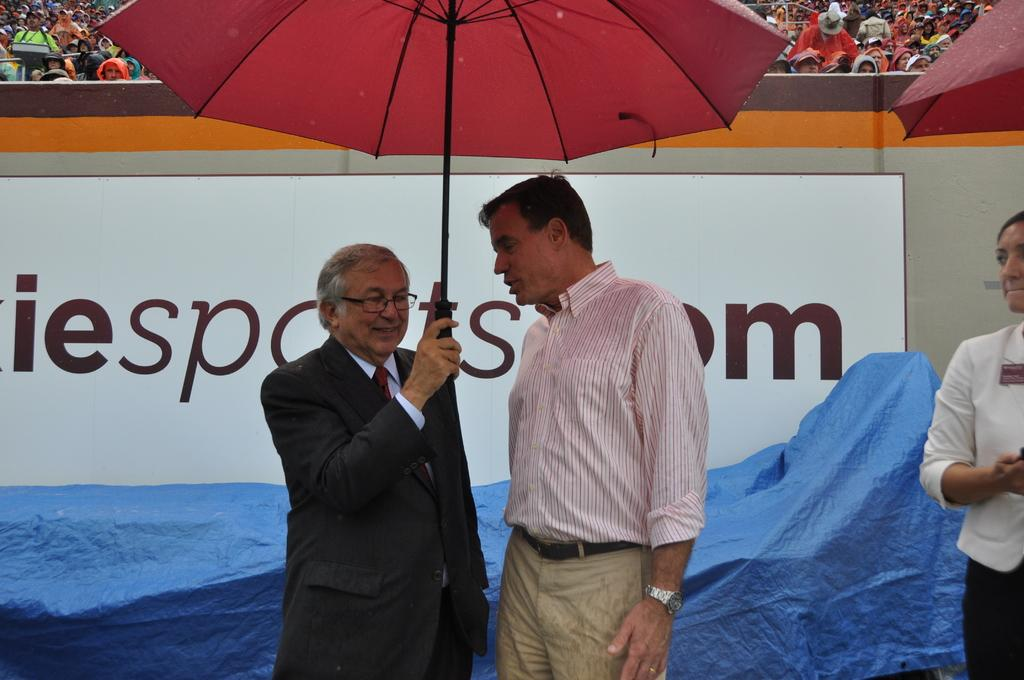How many people are standing in the image? There are three persons standing in the image. What are two of the persons holding? Two of the persons are holding umbrellas. What other objects can be seen in the image? There is a tarpaulin and a board in the image. What can be observed in the background of the image? There is a group of people in the background of the image. What type of snake is slithering under the tarpaulin in the image? There is no snake present in the image; it only features three persons, umbrellas, a tarpaulin, a board, and a group of people in the background. 